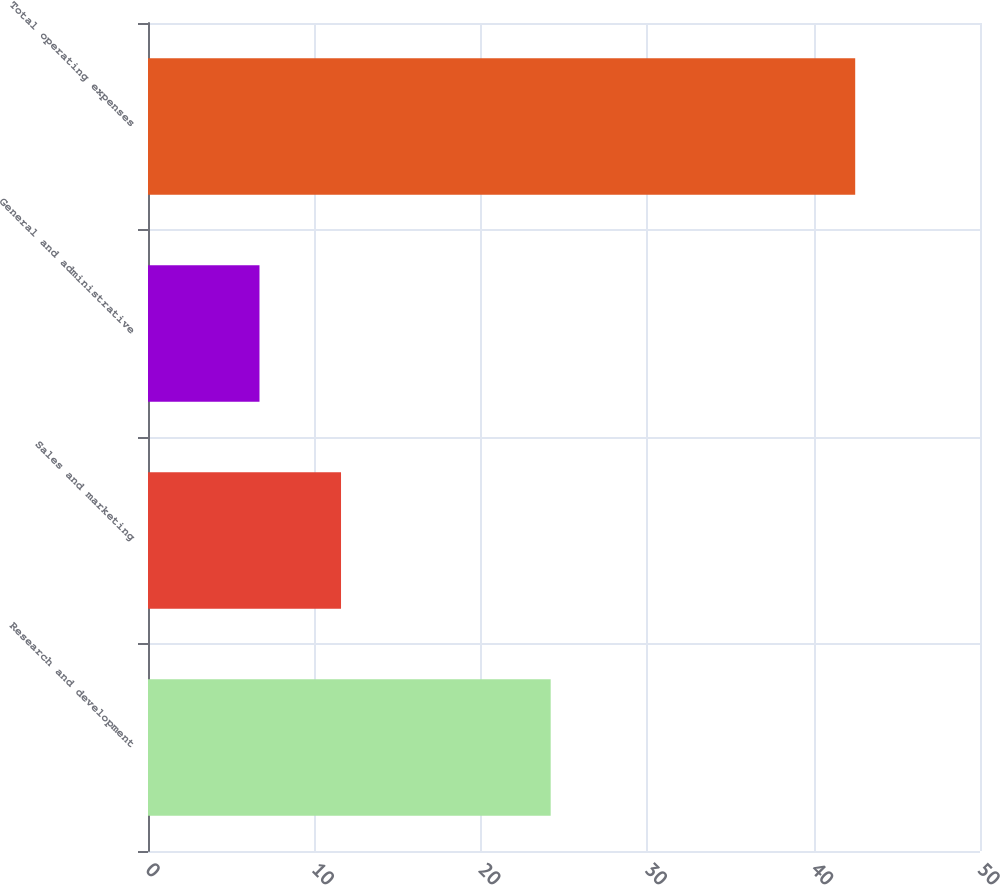Convert chart to OTSL. <chart><loc_0><loc_0><loc_500><loc_500><bar_chart><fcel>Research and development<fcel>Sales and marketing<fcel>General and administrative<fcel>Total operating expenses<nl><fcel>24.2<fcel>11.6<fcel>6.7<fcel>42.5<nl></chart> 